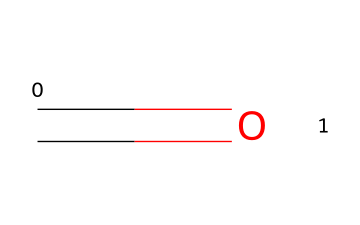What is the molecular formula of this chemical? The chemical composition shown by the SMILES represents formaldehyde, which consists of one carbon (C), one oxygen (O), and two hydrogen (H) atoms. Therefore, the molecular formula is CH2O.
Answer: CH2O How many carbon atoms are in this chemical? The SMILES notation indicates one "C" atom, representing one carbon atom in the chemical structure.
Answer: 1 What functional group does this chemical contain? The presence of the carbonyl group (C=O) in the structure indicates that formaldehyde contains an aldehyde functional group, which is characterized by a carbon atom double-bonded to an oxygen atom.
Answer: aldehyde Is this chemical considered hazardous? Formaldehyde is recognized as a hazardous substance due to its toxic and potentially carcinogenic properties, which can pose health risks.
Answer: yes What type of bond is represented in this chemical structure? The double bond represented by "C=O" in the SMILES denotes a covalent bond between carbon and oxygen, specifically a carbonyl bond found in carbonyl compounds.
Answer: covalent bond What is the common use of this chemical? Formaldehyde is widely used as a preservative in various industries, particularly in the production of resins and as a disinfectant.
Answer: preservative 